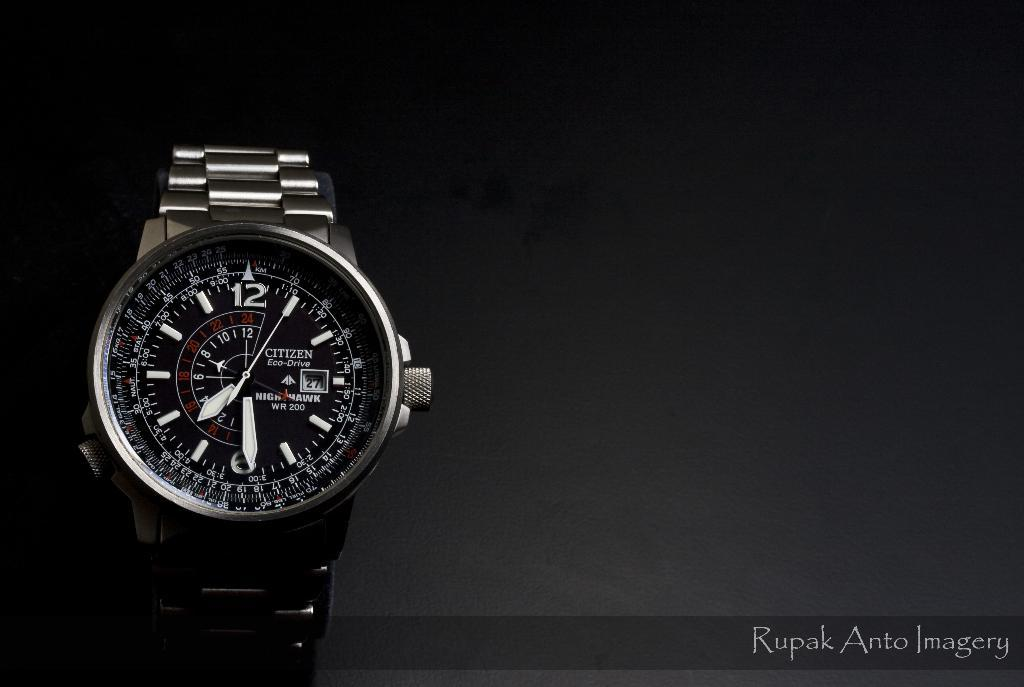Provide a one-sentence caption for the provided image. The black Citizen watch shows the multiple functions available. 